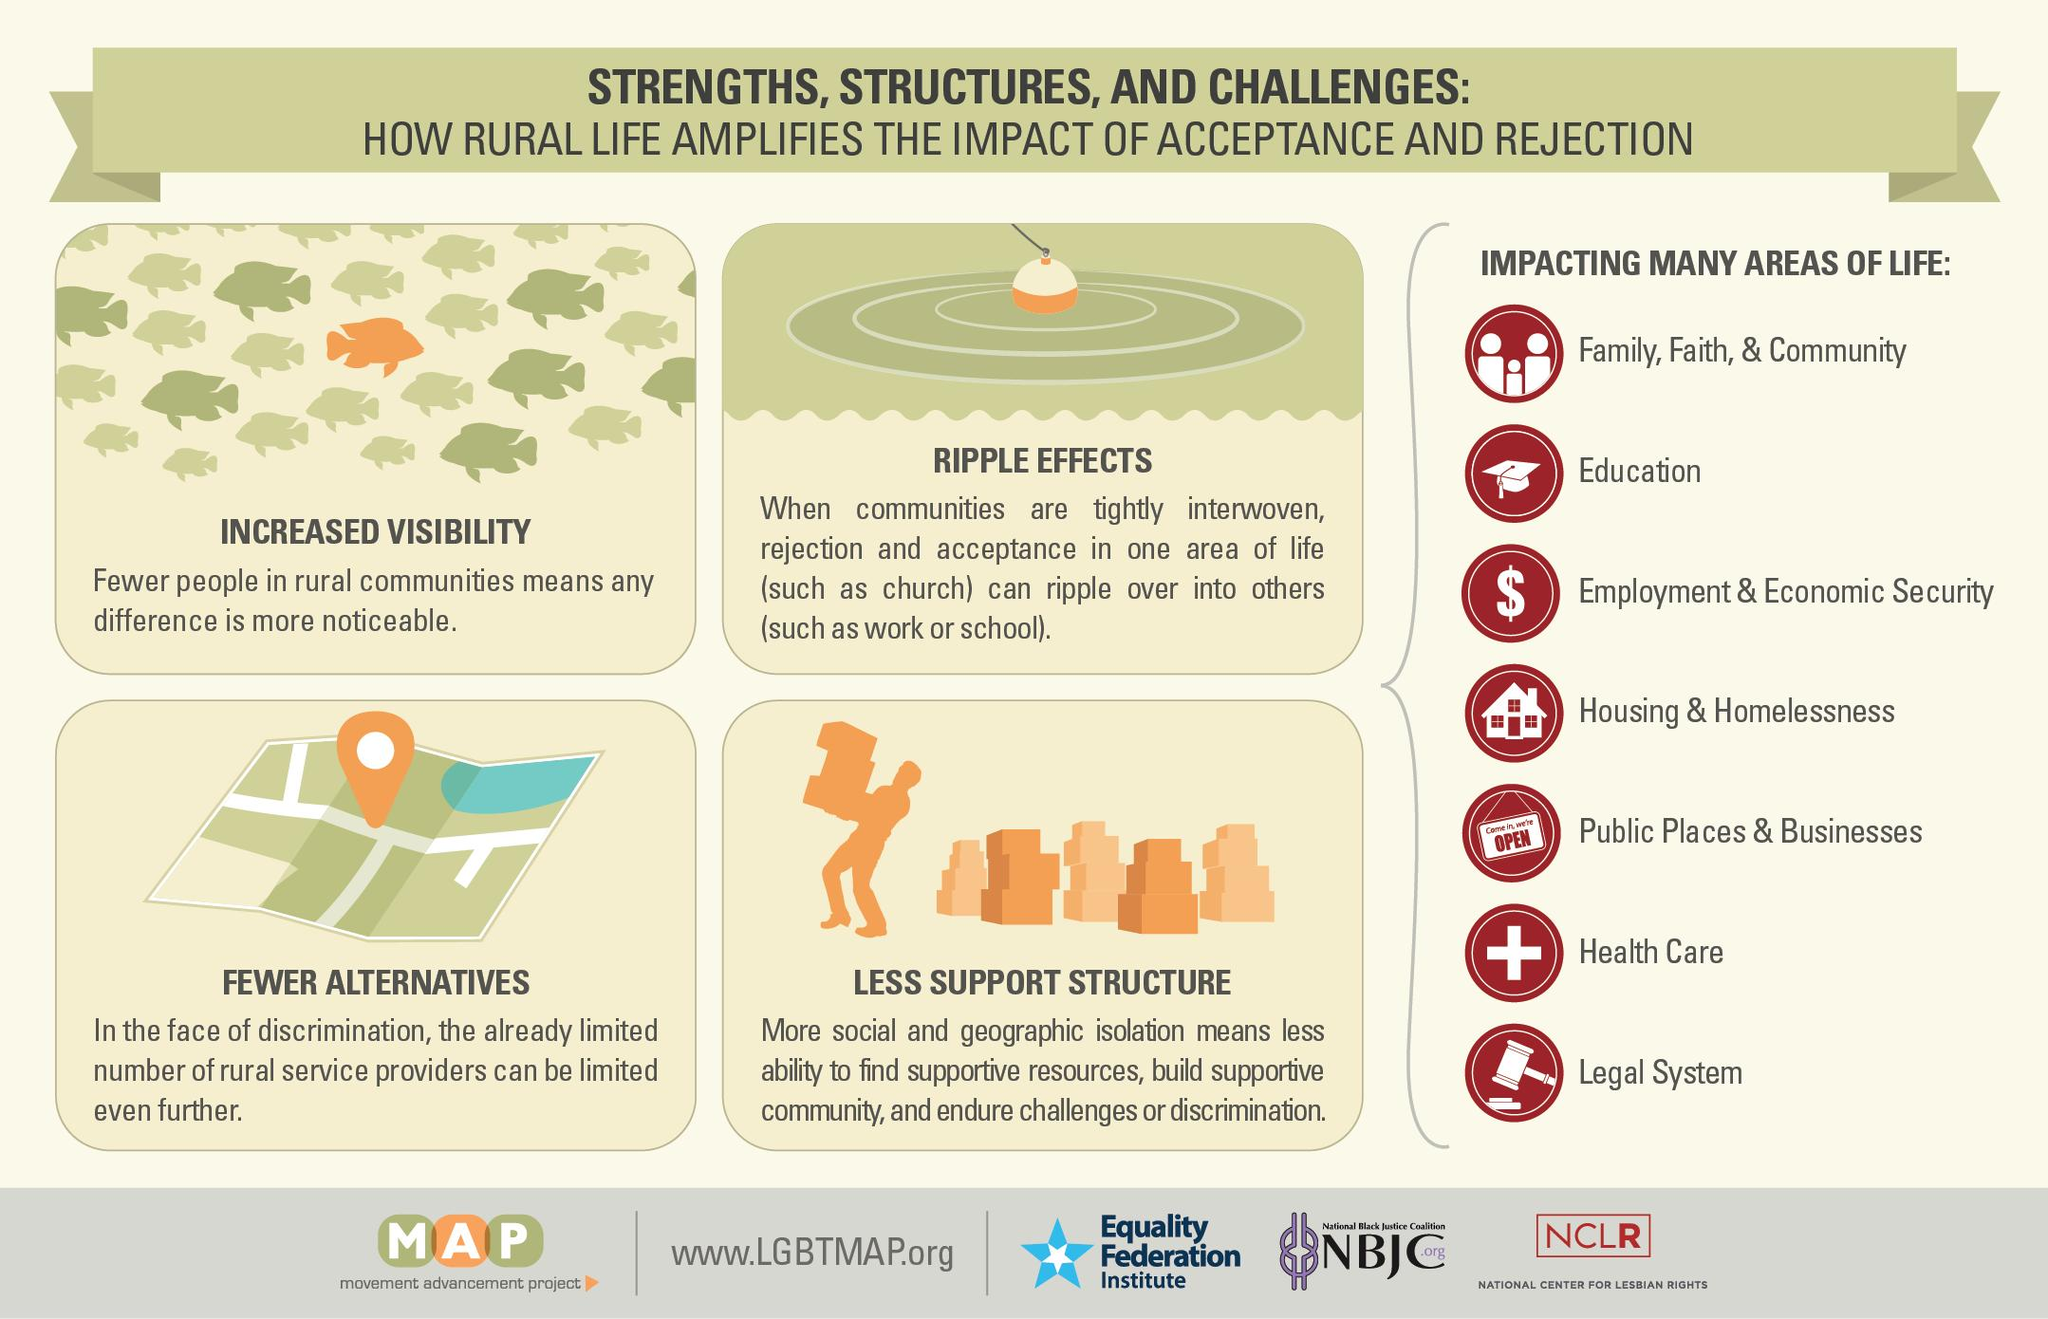Draw attention to some important aspects in this diagram. There are a total of 7 impacting areas of life listed. 